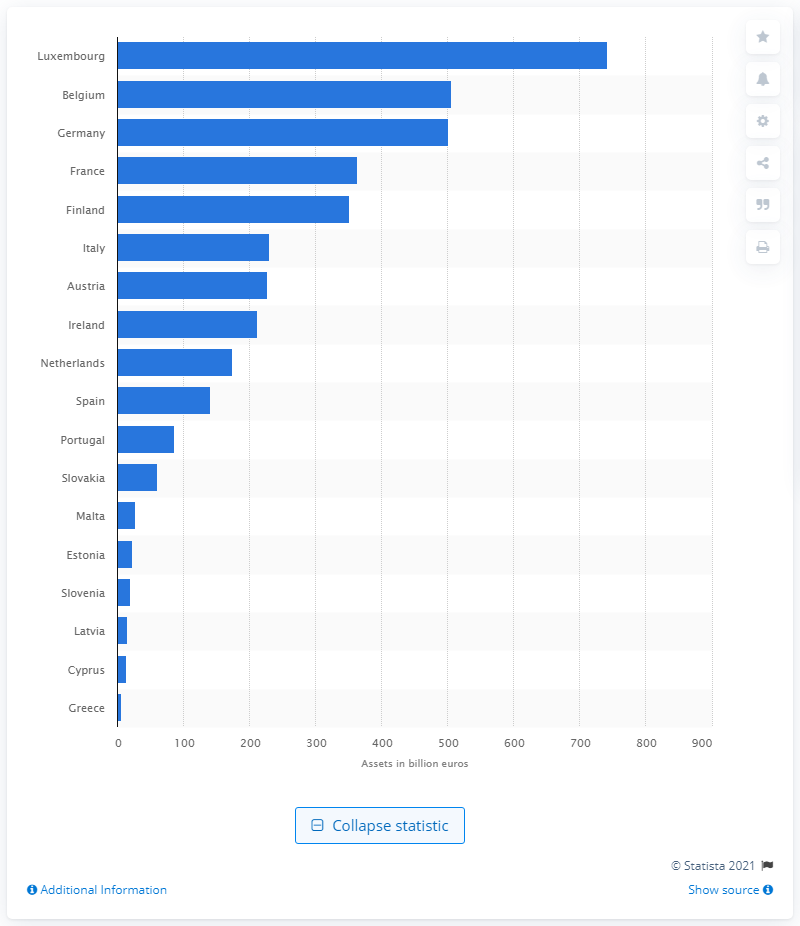Identify some key points in this picture. In 2016, Luxembourg's highest assets were valued at approximately 742.. 